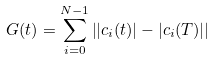<formula> <loc_0><loc_0><loc_500><loc_500>G ( t ) = \sum _ { i = 0 } ^ { N - 1 } \left | | c _ { i } ( t ) | - | c _ { i } ( T ) | \right |</formula> 